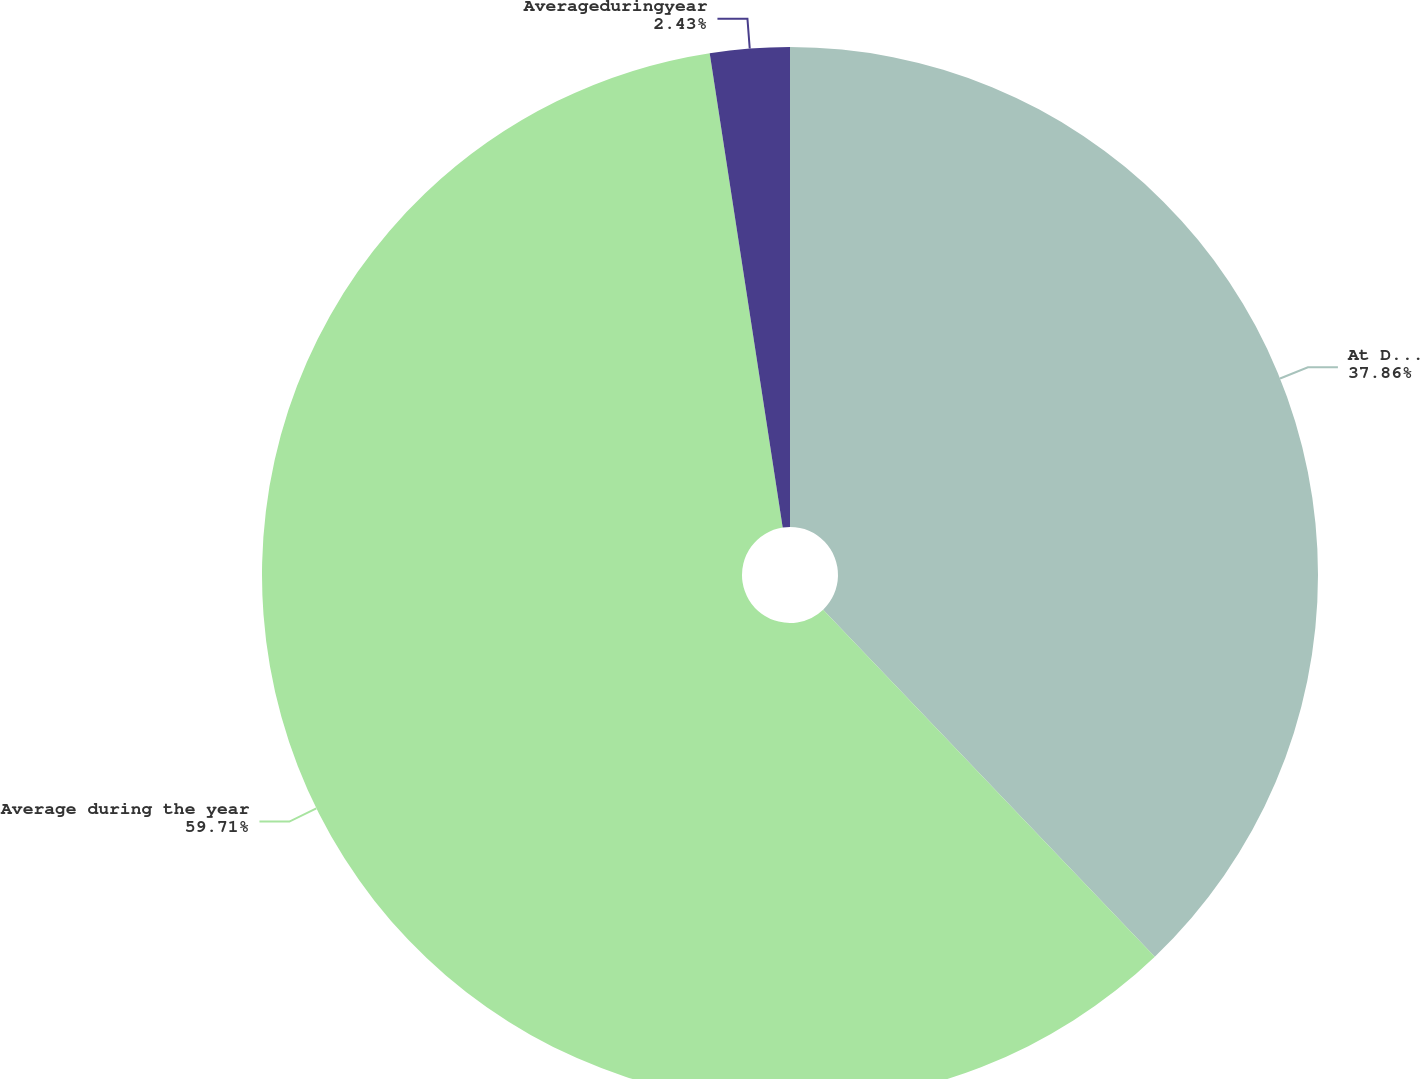Convert chart. <chart><loc_0><loc_0><loc_500><loc_500><pie_chart><fcel>At December 31<fcel>Average during the year<fcel>Averageduringyear<nl><fcel>37.86%<fcel>59.71%<fcel>2.43%<nl></chart> 